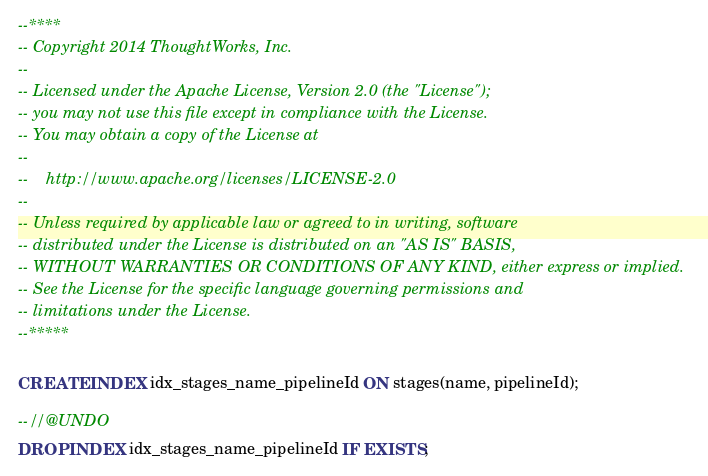<code> <loc_0><loc_0><loc_500><loc_500><_SQL_>--****
-- Copyright 2014 ThoughtWorks, Inc.
--
-- Licensed under the Apache License, Version 2.0 (the "License");
-- you may not use this file except in compliance with the License.
-- You may obtain a copy of the License at
--
--    http://www.apache.org/licenses/LICENSE-2.0
--
-- Unless required by applicable law or agreed to in writing, software
-- distributed under the License is distributed on an "AS IS" BASIS,
-- WITHOUT WARRANTIES OR CONDITIONS OF ANY KIND, either express or implied.
-- See the License for the specific language governing permissions and
-- limitations under the License.
--*****

CREATE INDEX idx_stages_name_pipelineId ON stages(name, pipelineId);

--//@UNDO
DROP INDEX idx_stages_name_pipelineId IF EXISTS;

</code> 